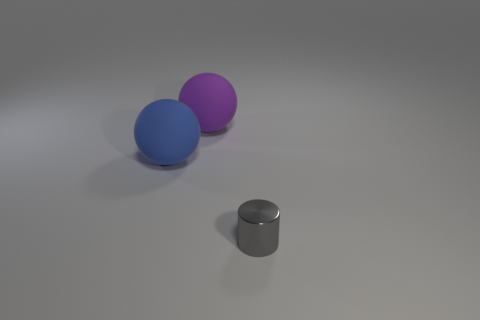Are there any blue objects that are behind the big matte thing that is in front of the big rubber ball that is right of the blue sphere?
Provide a short and direct response. No. Do the tiny gray object and the matte thing that is in front of the big purple matte ball have the same shape?
Make the answer very short. No. Is there any other thing of the same color as the tiny cylinder?
Ensure brevity in your answer.  No. Does the tiny object that is in front of the blue rubber sphere have the same color as the matte ball left of the large purple object?
Keep it short and to the point. No. Are any large blue matte spheres visible?
Provide a short and direct response. Yes. Is there a big red block that has the same material as the blue sphere?
Provide a succinct answer. No. Is there any other thing that has the same material as the purple ball?
Provide a short and direct response. Yes. What is the color of the cylinder?
Your response must be concise. Gray. What is the color of the thing that is the same size as the blue rubber ball?
Make the answer very short. Purple. How many shiny things are large yellow cylinders or big purple balls?
Make the answer very short. 0. 